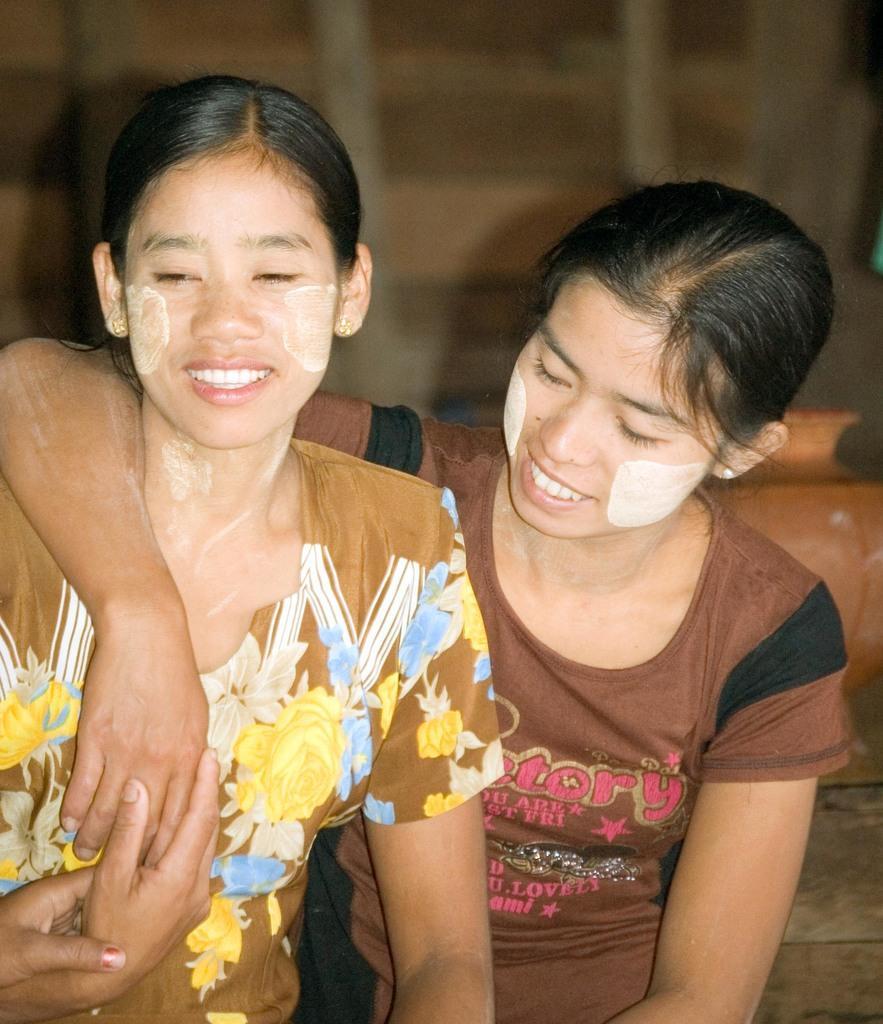Can you describe this image briefly? In this image I can see two women wearing brown , black, blue and yellow colored dress are smiling. In the background I can see few blurry objects and a pot which is brown in color. 